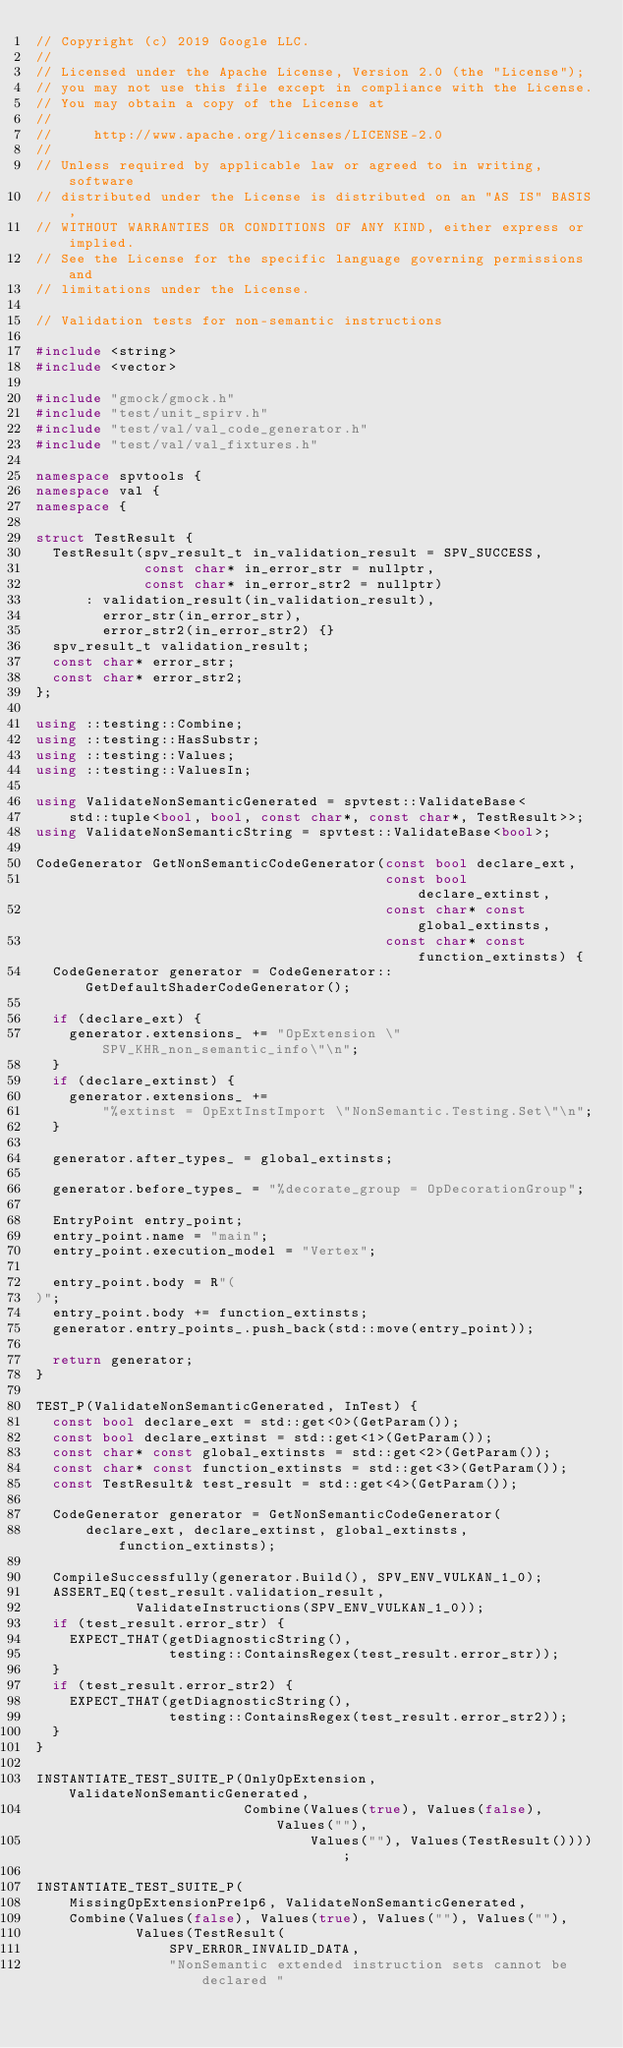Convert code to text. <code><loc_0><loc_0><loc_500><loc_500><_C++_>// Copyright (c) 2019 Google LLC.
//
// Licensed under the Apache License, Version 2.0 (the "License");
// you may not use this file except in compliance with the License.
// You may obtain a copy of the License at
//
//     http://www.apache.org/licenses/LICENSE-2.0
//
// Unless required by applicable law or agreed to in writing, software
// distributed under the License is distributed on an "AS IS" BASIS,
// WITHOUT WARRANTIES OR CONDITIONS OF ANY KIND, either express or implied.
// See the License for the specific language governing permissions and
// limitations under the License.

// Validation tests for non-semantic instructions

#include <string>
#include <vector>

#include "gmock/gmock.h"
#include "test/unit_spirv.h"
#include "test/val/val_code_generator.h"
#include "test/val/val_fixtures.h"

namespace spvtools {
namespace val {
namespace {

struct TestResult {
  TestResult(spv_result_t in_validation_result = SPV_SUCCESS,
             const char* in_error_str = nullptr,
             const char* in_error_str2 = nullptr)
      : validation_result(in_validation_result),
        error_str(in_error_str),
        error_str2(in_error_str2) {}
  spv_result_t validation_result;
  const char* error_str;
  const char* error_str2;
};

using ::testing::Combine;
using ::testing::HasSubstr;
using ::testing::Values;
using ::testing::ValuesIn;

using ValidateNonSemanticGenerated = spvtest::ValidateBase<
    std::tuple<bool, bool, const char*, const char*, TestResult>>;
using ValidateNonSemanticString = spvtest::ValidateBase<bool>;

CodeGenerator GetNonSemanticCodeGenerator(const bool declare_ext,
                                          const bool declare_extinst,
                                          const char* const global_extinsts,
                                          const char* const function_extinsts) {
  CodeGenerator generator = CodeGenerator::GetDefaultShaderCodeGenerator();

  if (declare_ext) {
    generator.extensions_ += "OpExtension \"SPV_KHR_non_semantic_info\"\n";
  }
  if (declare_extinst) {
    generator.extensions_ +=
        "%extinst = OpExtInstImport \"NonSemantic.Testing.Set\"\n";
  }

  generator.after_types_ = global_extinsts;

  generator.before_types_ = "%decorate_group = OpDecorationGroup";

  EntryPoint entry_point;
  entry_point.name = "main";
  entry_point.execution_model = "Vertex";

  entry_point.body = R"(
)";
  entry_point.body += function_extinsts;
  generator.entry_points_.push_back(std::move(entry_point));

  return generator;
}

TEST_P(ValidateNonSemanticGenerated, InTest) {
  const bool declare_ext = std::get<0>(GetParam());
  const bool declare_extinst = std::get<1>(GetParam());
  const char* const global_extinsts = std::get<2>(GetParam());
  const char* const function_extinsts = std::get<3>(GetParam());
  const TestResult& test_result = std::get<4>(GetParam());

  CodeGenerator generator = GetNonSemanticCodeGenerator(
      declare_ext, declare_extinst, global_extinsts, function_extinsts);

  CompileSuccessfully(generator.Build(), SPV_ENV_VULKAN_1_0);
  ASSERT_EQ(test_result.validation_result,
            ValidateInstructions(SPV_ENV_VULKAN_1_0));
  if (test_result.error_str) {
    EXPECT_THAT(getDiagnosticString(),
                testing::ContainsRegex(test_result.error_str));
  }
  if (test_result.error_str2) {
    EXPECT_THAT(getDiagnosticString(),
                testing::ContainsRegex(test_result.error_str2));
  }
}

INSTANTIATE_TEST_SUITE_P(OnlyOpExtension, ValidateNonSemanticGenerated,
                         Combine(Values(true), Values(false), Values(""),
                                 Values(""), Values(TestResult())));

INSTANTIATE_TEST_SUITE_P(
    MissingOpExtensionPre1p6, ValidateNonSemanticGenerated,
    Combine(Values(false), Values(true), Values(""), Values(""),
            Values(TestResult(
                SPV_ERROR_INVALID_DATA,
                "NonSemantic extended instruction sets cannot be declared "</code> 